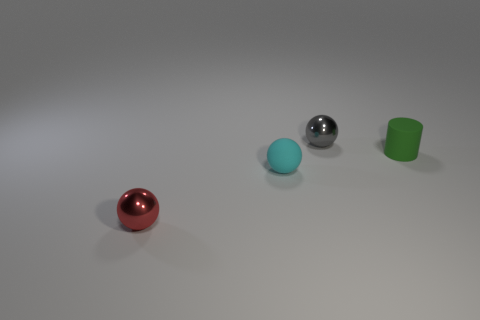Add 2 large brown cubes. How many objects exist? 6 Subtract all small metallic balls. How many balls are left? 1 Subtract all cyan spheres. How many spheres are left? 2 Subtract all blue balls. Subtract all gray blocks. How many balls are left? 3 Subtract 0 purple spheres. How many objects are left? 4 Subtract all cylinders. How many objects are left? 3 Subtract 3 spheres. How many spheres are left? 0 Subtract all cylinders. Subtract all red metallic things. How many objects are left? 2 Add 1 tiny red metal balls. How many tiny red metal balls are left? 2 Add 2 purple balls. How many purple balls exist? 2 